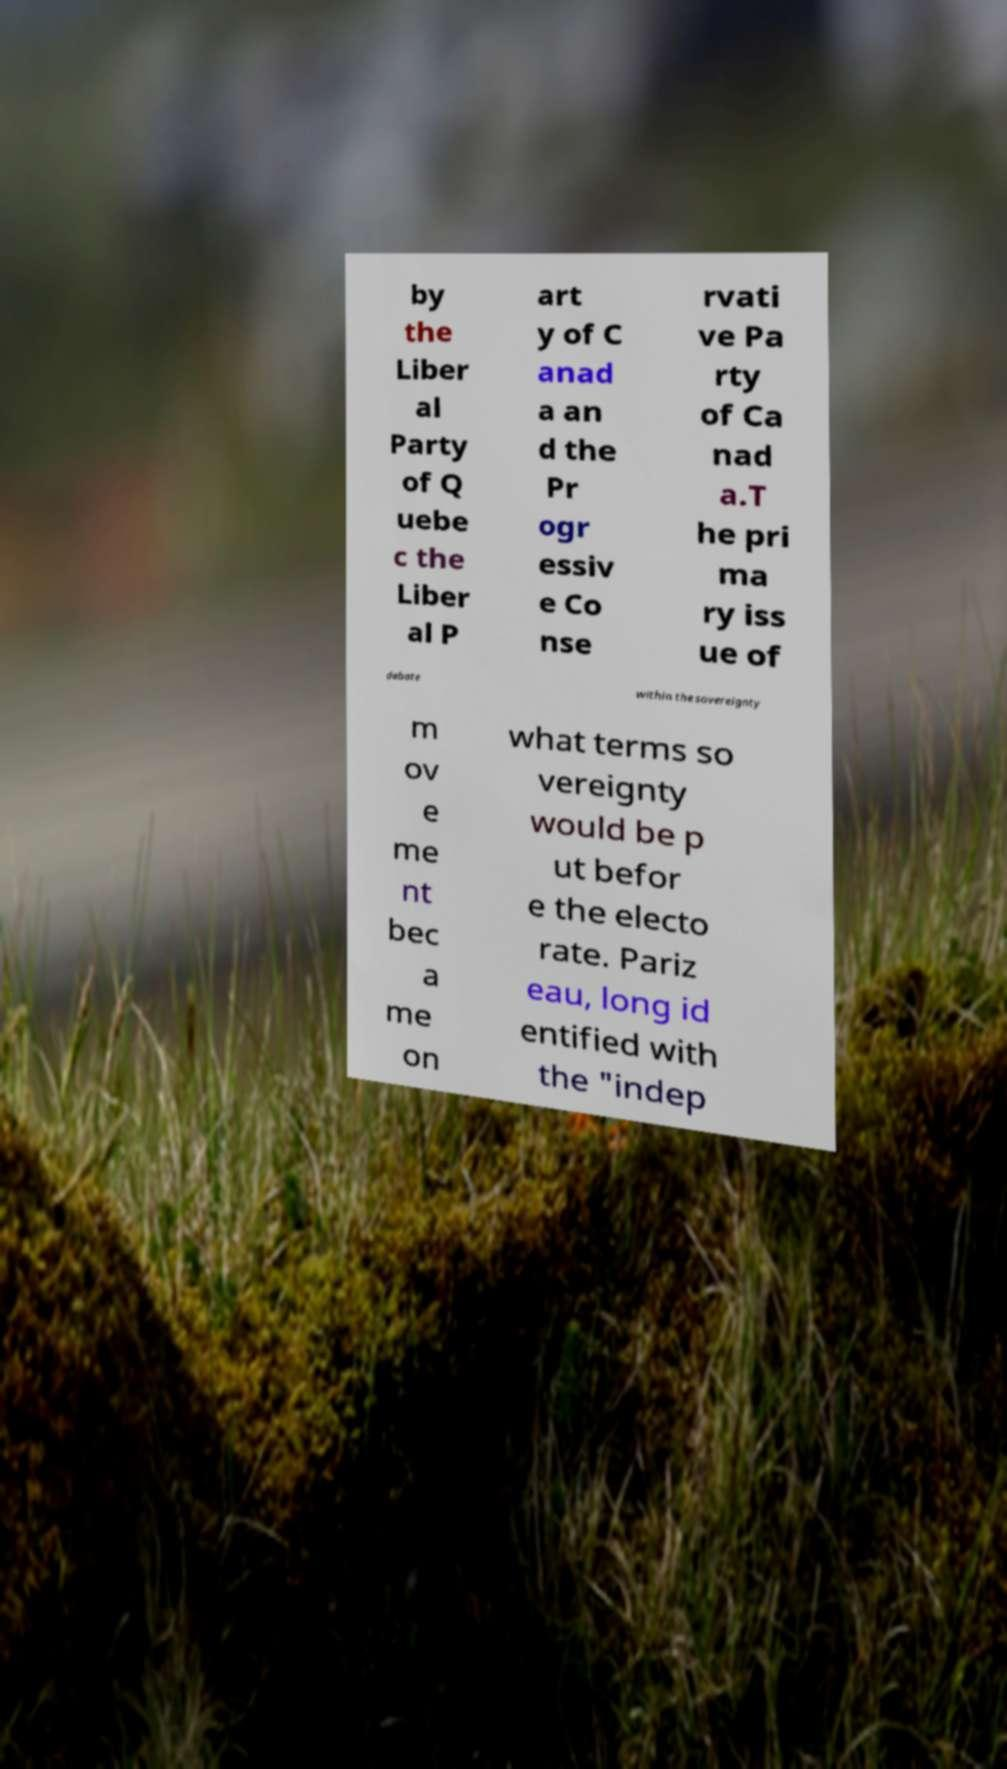Please read and relay the text visible in this image. What does it say? by the Liber al Party of Q uebe c the Liber al P art y of C anad a an d the Pr ogr essiv e Co nse rvati ve Pa rty of Ca nad a.T he pri ma ry iss ue of debate within the sovereignty m ov e me nt bec a me on what terms so vereignty would be p ut befor e the electo rate. Pariz eau, long id entified with the "indep 